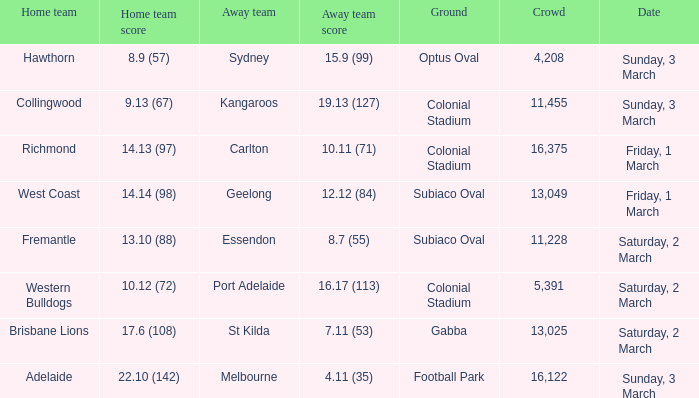Who is the away team when the home team scored 17.6 (108)? St Kilda. 